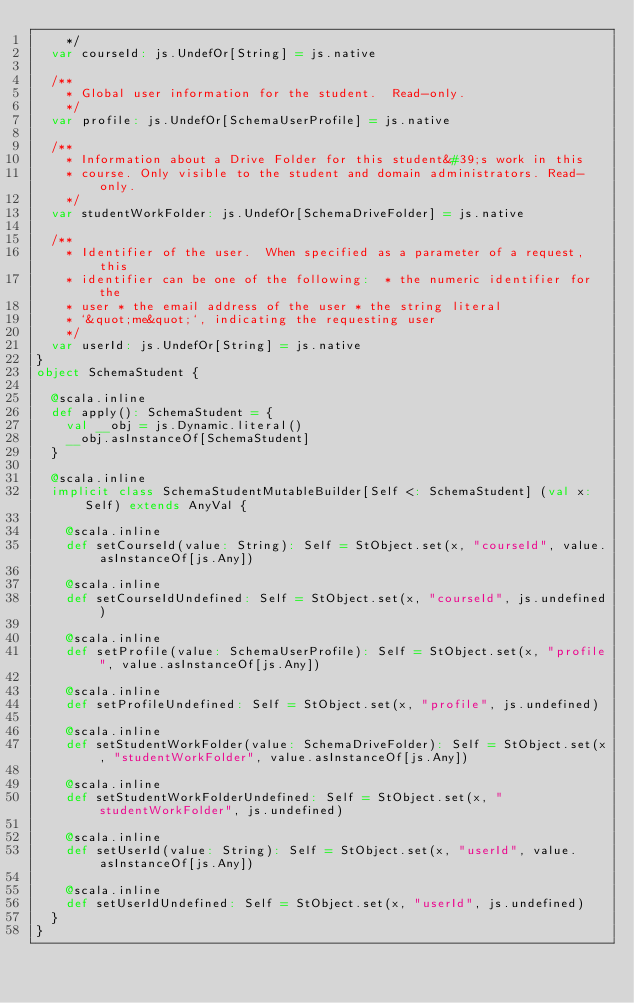Convert code to text. <code><loc_0><loc_0><loc_500><loc_500><_Scala_>    */
  var courseId: js.UndefOr[String] = js.native
  
  /**
    * Global user information for the student.  Read-only.
    */
  var profile: js.UndefOr[SchemaUserProfile] = js.native
  
  /**
    * Information about a Drive Folder for this student&#39;s work in this
    * course. Only visible to the student and domain administrators. Read-only.
    */
  var studentWorkFolder: js.UndefOr[SchemaDriveFolder] = js.native
  
  /**
    * Identifier of the user.  When specified as a parameter of a request, this
    * identifier can be one of the following:  * the numeric identifier for the
    * user * the email address of the user * the string literal
    * `&quot;me&quot;`, indicating the requesting user
    */
  var userId: js.UndefOr[String] = js.native
}
object SchemaStudent {
  
  @scala.inline
  def apply(): SchemaStudent = {
    val __obj = js.Dynamic.literal()
    __obj.asInstanceOf[SchemaStudent]
  }
  
  @scala.inline
  implicit class SchemaStudentMutableBuilder[Self <: SchemaStudent] (val x: Self) extends AnyVal {
    
    @scala.inline
    def setCourseId(value: String): Self = StObject.set(x, "courseId", value.asInstanceOf[js.Any])
    
    @scala.inline
    def setCourseIdUndefined: Self = StObject.set(x, "courseId", js.undefined)
    
    @scala.inline
    def setProfile(value: SchemaUserProfile): Self = StObject.set(x, "profile", value.asInstanceOf[js.Any])
    
    @scala.inline
    def setProfileUndefined: Self = StObject.set(x, "profile", js.undefined)
    
    @scala.inline
    def setStudentWorkFolder(value: SchemaDriveFolder): Self = StObject.set(x, "studentWorkFolder", value.asInstanceOf[js.Any])
    
    @scala.inline
    def setStudentWorkFolderUndefined: Self = StObject.set(x, "studentWorkFolder", js.undefined)
    
    @scala.inline
    def setUserId(value: String): Self = StObject.set(x, "userId", value.asInstanceOf[js.Any])
    
    @scala.inline
    def setUserIdUndefined: Self = StObject.set(x, "userId", js.undefined)
  }
}
</code> 